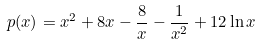Convert formula to latex. <formula><loc_0><loc_0><loc_500><loc_500>p ( x ) = x ^ { 2 } + 8 x - \frac { 8 } { x } - \frac { 1 } { x ^ { 2 } } + 1 2 \ln x</formula> 